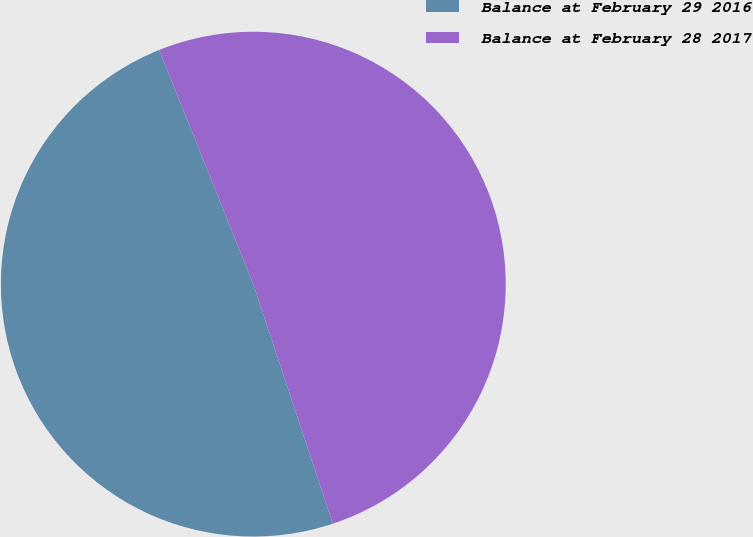<chart> <loc_0><loc_0><loc_500><loc_500><pie_chart><fcel>Balance at February 29 2016<fcel>Balance at February 28 2017<nl><fcel>49.02%<fcel>50.98%<nl></chart> 